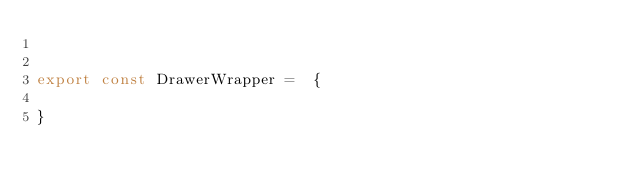<code> <loc_0><loc_0><loc_500><loc_500><_JavaScript_>

export const DrawerWrapper =  {
  
}</code> 